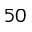<formula> <loc_0><loc_0><loc_500><loc_500>5 0</formula> 